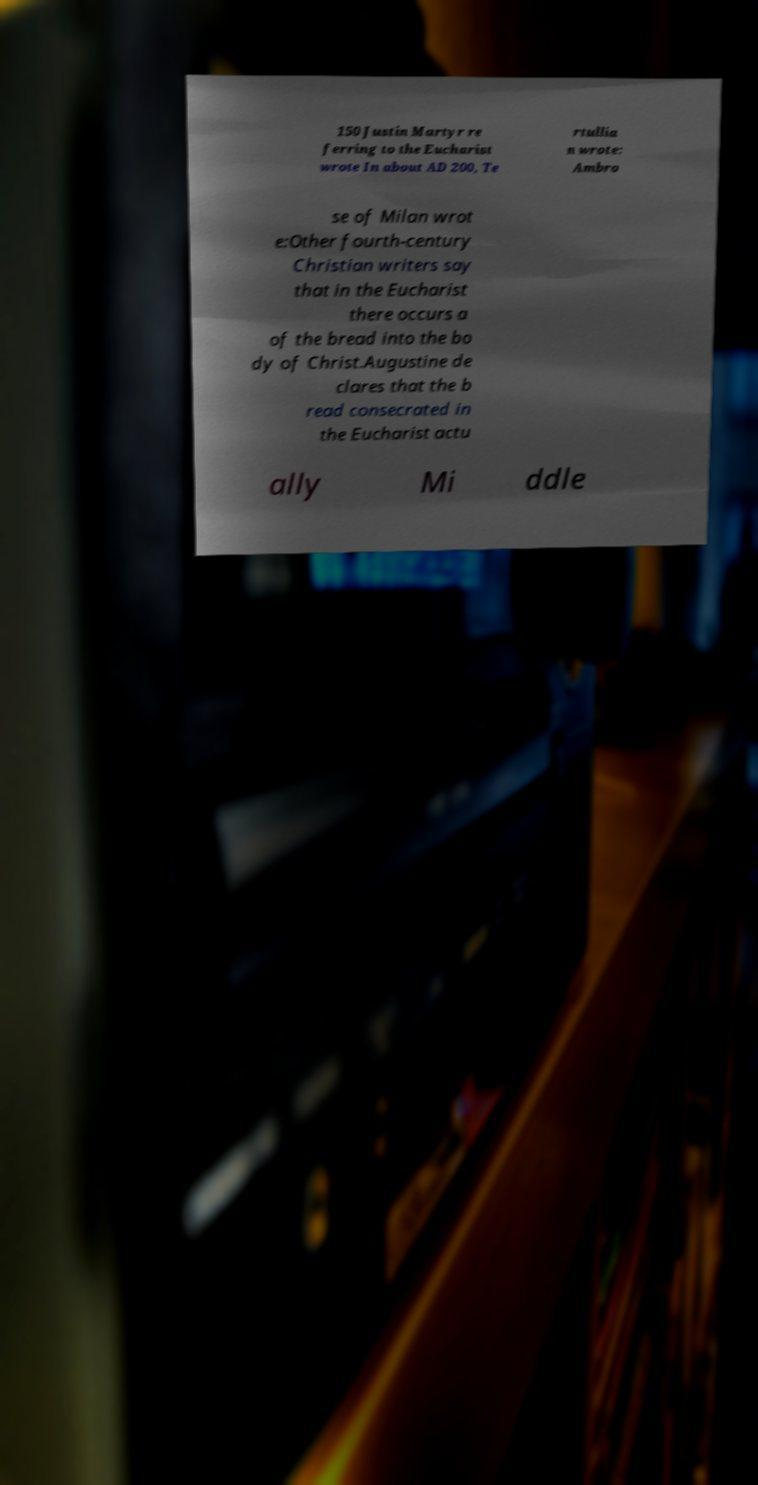Can you read and provide the text displayed in the image?This photo seems to have some interesting text. Can you extract and type it out for me? 150 Justin Martyr re ferring to the Eucharist wrote In about AD 200, Te rtullia n wrote: Ambro se of Milan wrot e:Other fourth-century Christian writers say that in the Eucharist there occurs a of the bread into the bo dy of Christ.Augustine de clares that the b read consecrated in the Eucharist actu ally Mi ddle 